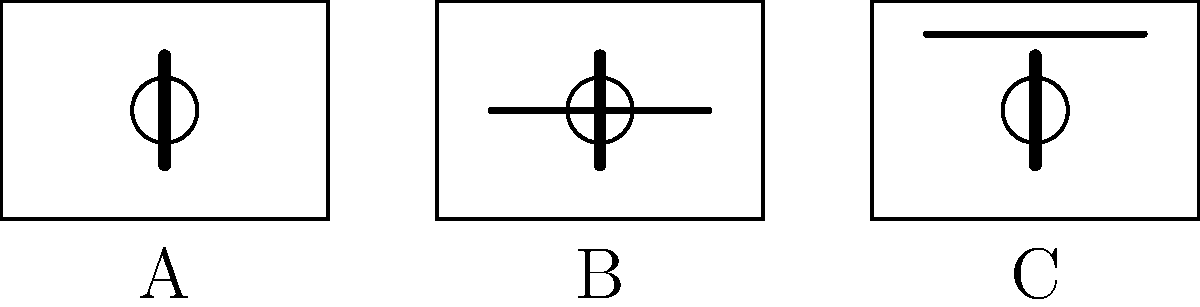Which crib setup (A, B, or C) represents the safest sleep position for a baby according to current guidelines? To determine the safest sleep position for a baby, let's analyze each crib setup:

1. Crib A:
   - The baby is placed on their back.
   - There are no loose items or bedding in the crib.
   - The crib is empty except for the baby.

2. Crib B:
   - The baby is placed on their back.
   - There is a horizontal line across the crib, which could represent a blanket or other loose item.
   - Loose items in the crib pose a suffocation risk.

3. Crib C:
   - The baby is placed on their back.
   - There is a horizontal line near the top of the crib, which could represent a mobile or other hanging item.
   - Hanging items pose a strangulation risk if the baby can reach them.

Current safe sleep guidelines recommend:
- Always place babies on their back to sleep.
- Use a firm, flat sleep surface.
- Keep the crib free of loose items, including blankets, pillows, and toys.
- Avoid the use of crib bumpers, which can pose suffocation risks.
- Keep mobiles and hanging toys out of the baby's reach.

Based on these guidelines, Crib A represents the safest sleep environment for a baby. It shows the baby on their back with no additional items in the crib that could pose a risk.
Answer: A 